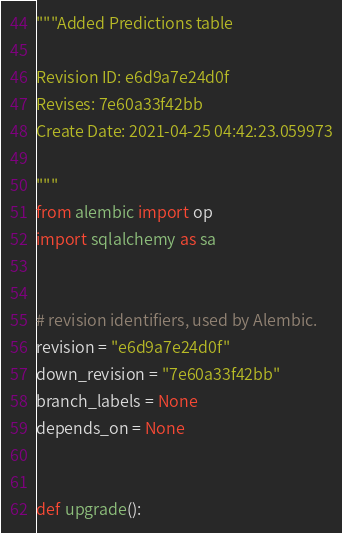<code> <loc_0><loc_0><loc_500><loc_500><_Python_>"""Added Predictions table

Revision ID: e6d9a7e24d0f
Revises: 7e60a33f42bb
Create Date: 2021-04-25 04:42:23.059973

"""
from alembic import op
import sqlalchemy as sa


# revision identifiers, used by Alembic.
revision = "e6d9a7e24d0f"
down_revision = "7e60a33f42bb"
branch_labels = None
depends_on = None


def upgrade():</code> 